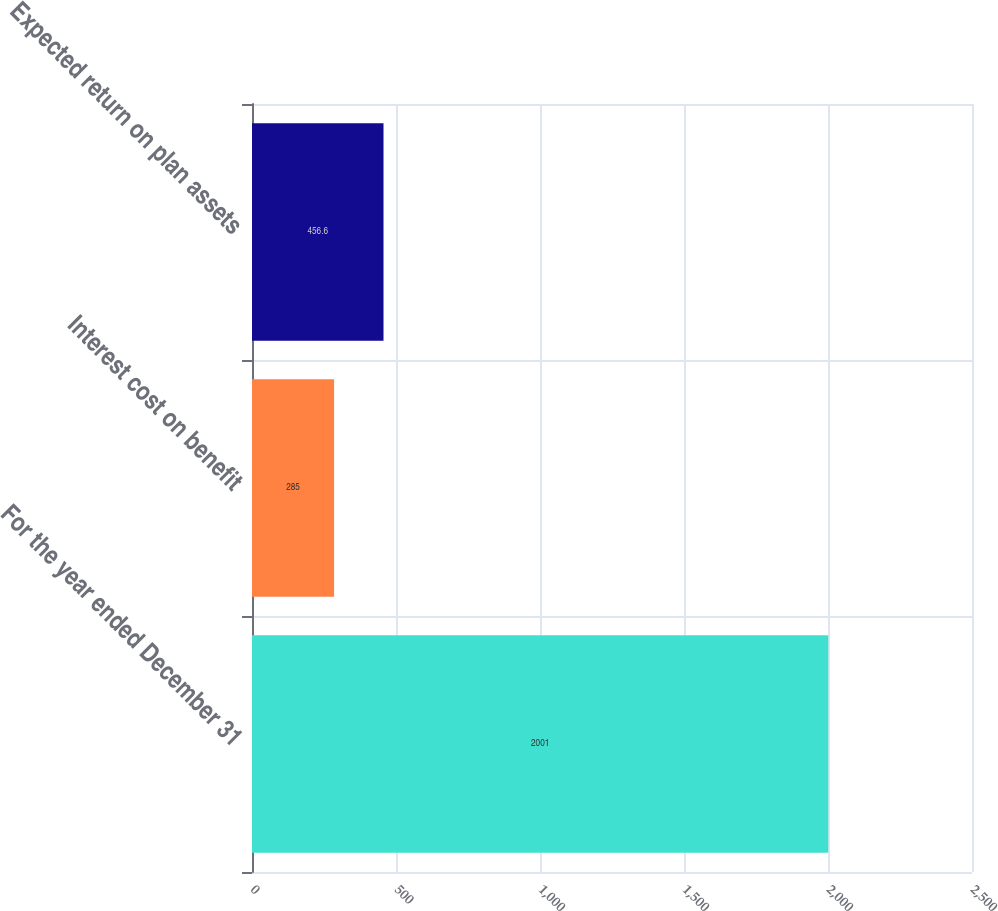Convert chart to OTSL. <chart><loc_0><loc_0><loc_500><loc_500><bar_chart><fcel>For the year ended December 31<fcel>Interest cost on benefit<fcel>Expected return on plan assets<nl><fcel>2001<fcel>285<fcel>456.6<nl></chart> 